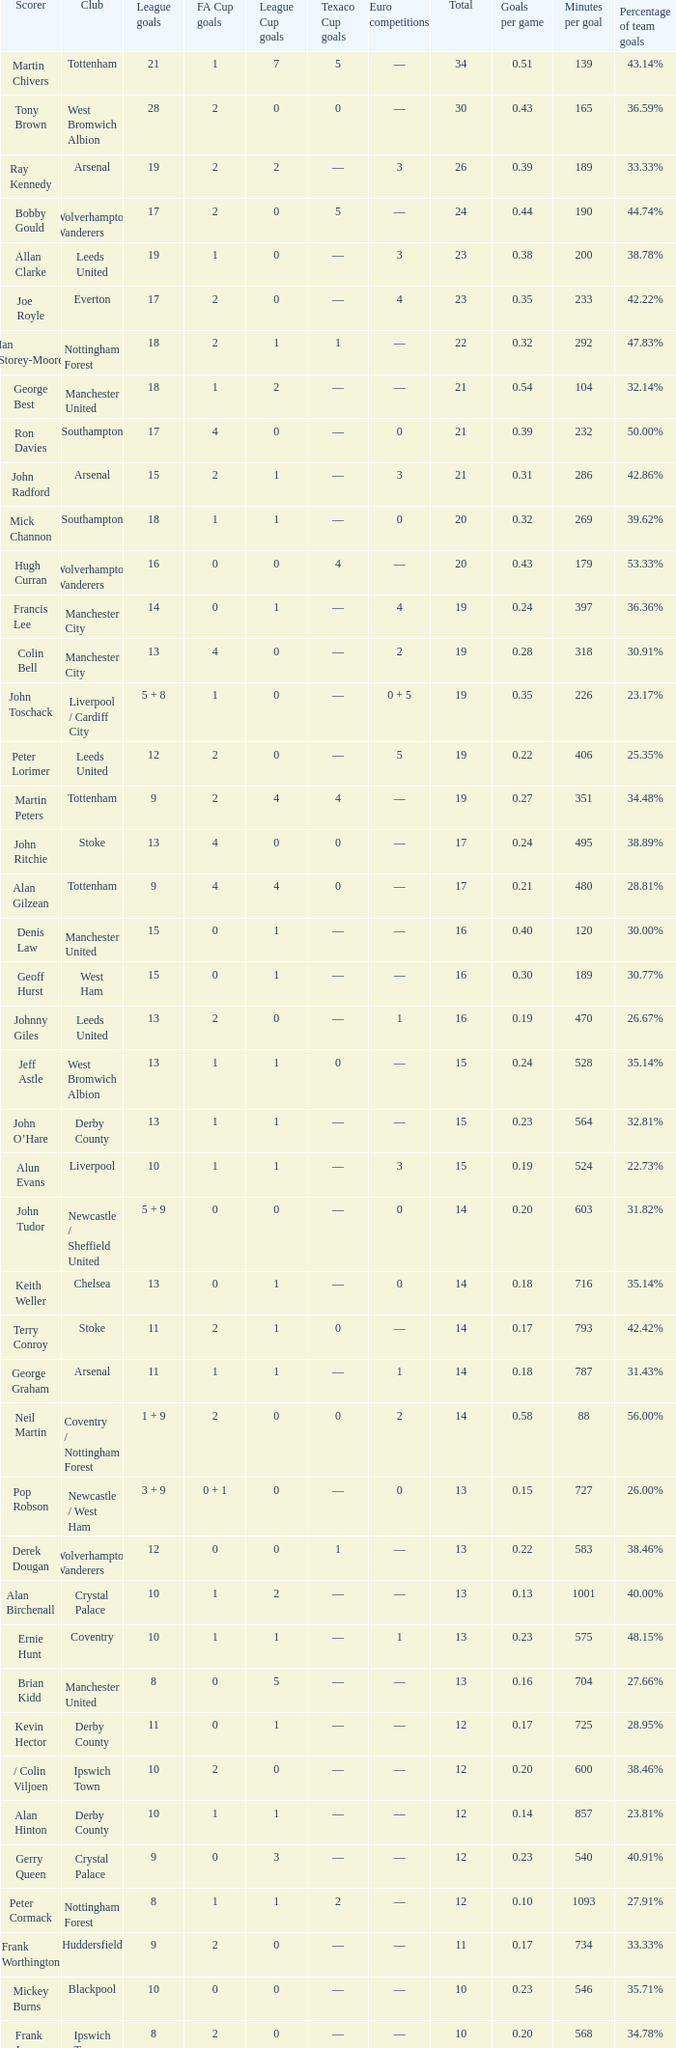What is the average Total, when FA Cup Goals is 1, when League Goals is 10, and when Club is Crystal Palace? 13.0. 